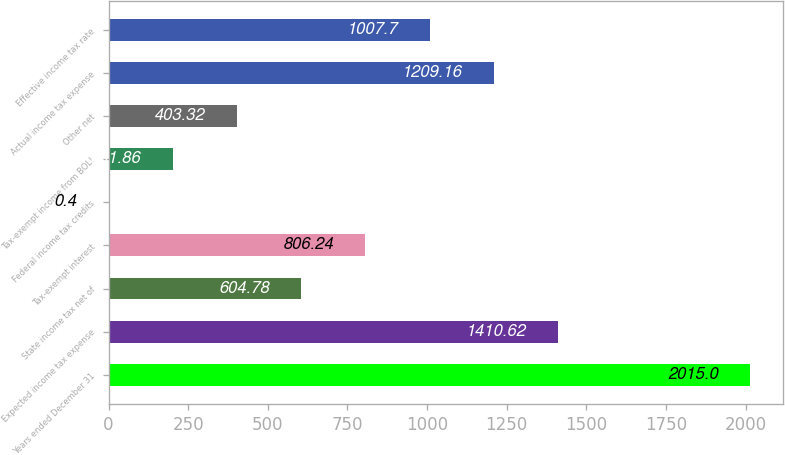<chart> <loc_0><loc_0><loc_500><loc_500><bar_chart><fcel>Years ended December 31<fcel>Expected income tax expense<fcel>State income tax net of<fcel>Tax-exempt interest<fcel>Federal income tax credits<fcel>Tax-exempt income from BOLI<fcel>Other net<fcel>Actual income tax expense<fcel>Effective income tax rate<nl><fcel>2015<fcel>1410.62<fcel>604.78<fcel>806.24<fcel>0.4<fcel>201.86<fcel>403.32<fcel>1209.16<fcel>1007.7<nl></chart> 